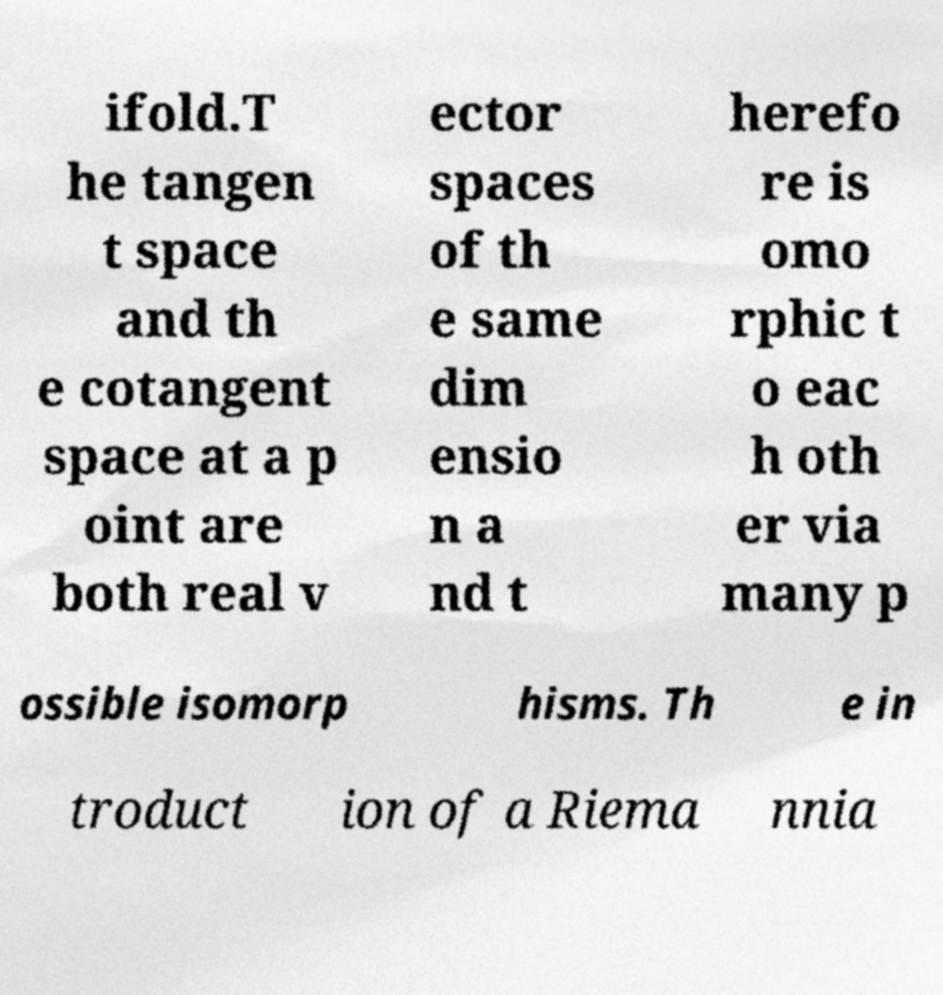Can you accurately transcribe the text from the provided image for me? ifold.T he tangen t space and th e cotangent space at a p oint are both real v ector spaces of th e same dim ensio n a nd t herefo re is omo rphic t o eac h oth er via many p ossible isomorp hisms. Th e in troduct ion of a Riema nnia 